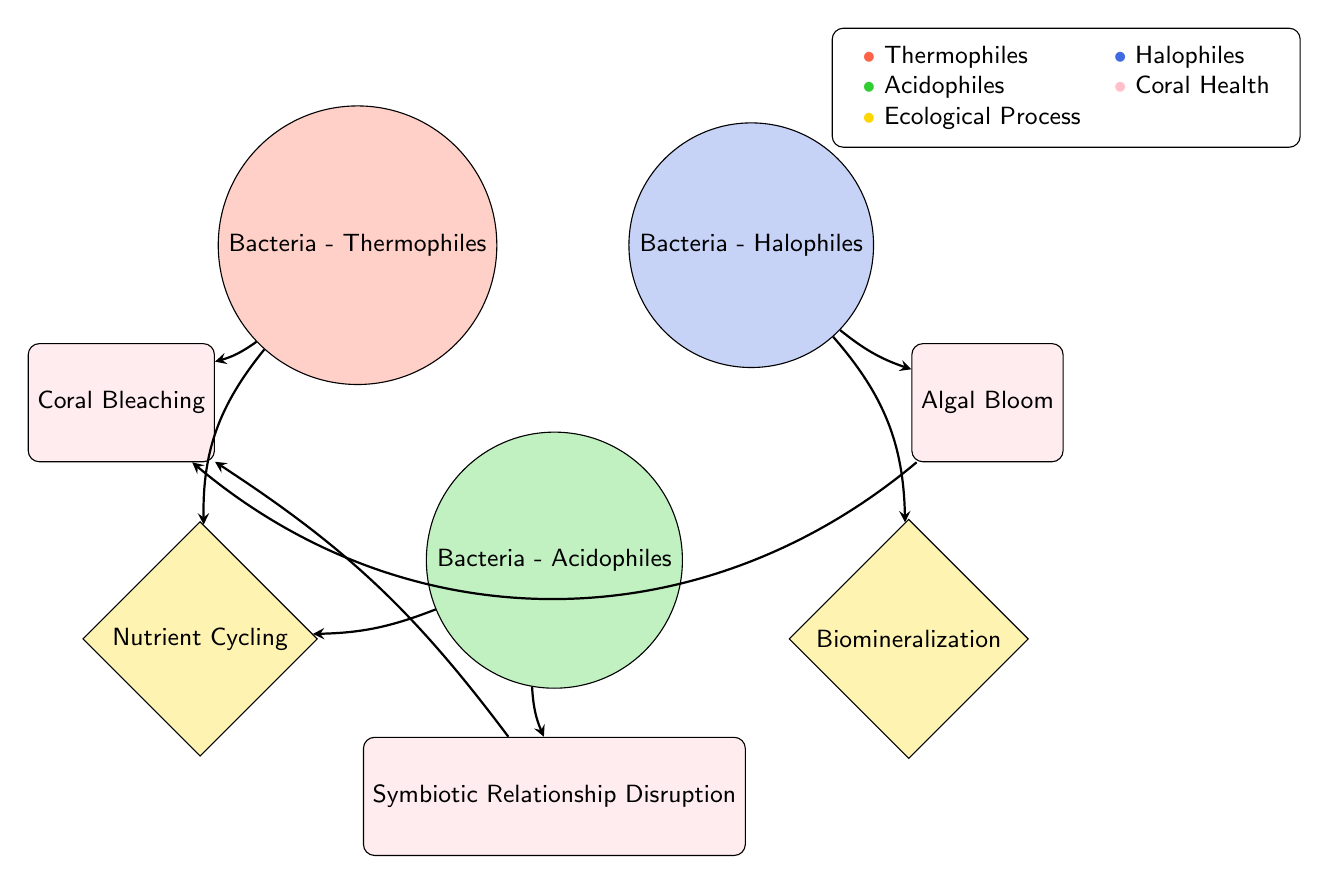What are the primary groups represented in the diagram? The diagram includes three primary groups: Extremophiles, Coral Reef Health, and Ecological Processes. Each group contains specific types of nodes that illustrate the impacts of extremophiles on coral reef health and ecological processes.
Answer: Extremophiles, Coral Reef Health, Ecological Processes How many nodes are there in total? By counting the distinct nodes listed in the data under "nodes", we find there are eight nodes in total.
Answer: 8 Which extremophile is linked to Coral Bleaching? Referring to the links in the diagram, Bacteria - Thermophiles and Symbiotic Relationship Disruption both connect to Coral Bleaching, indicating a direct impact.
Answer: Bacteria - Thermophiles What is the link value between Bacteria - Halophiles and Algal Bloom? The link data specifies a value of 1 between Bacteria - Halophiles and Algal Bloom, indicating a single direct connection in the relationship chain.
Answer: 1 Which ecological process is associated with both Bacteria - Thermophiles and Bacteria - Acidophiles? Both extremophiles connect to Nutrient Cycling, as indicated by the links, showing their contribution to this ecological process.
Answer: Nutrient Cycling How does Symbiotic Relationship Disruption relate to Coral Bleaching? The diagram shows a direct link from Symbiotic Relationship Disruption to Coral Bleaching, suggesting that disruptions in symbiosis may lead to coral stress and bleaching events.
Answer: Direct link Which extremophile affects Biomineralization? According to the connections shown in the diagram, Bacteria - Halophiles is linked to Biomineralization, indicating its role in this ecological process.
Answer: Bacteria - Halophiles What two processes are influenced by Bacteria - Acidophiles? Analyzing the connections, Bacteria - Acidophiles impacts both Symbiotic Relationship Disruption and Nutrient Cycling, demonstrating its dual role in the ecosystem.
Answer: Symbiotic Relationship Disruption and Nutrient Cycling Which coral reef health consequence results from an Algal Bloom? The diagram indicates that an Algal Bloom has a direct link to Coral Bleaching, suggesting that algal blooms can lead to stress and bleaching in coral reefs.
Answer: Coral Bleaching 